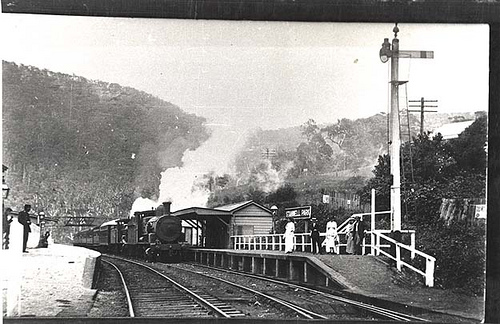<image>What time of year is this? It is ambiguous to determine the exact time of year, but it could be winter. What time of year is this? I don't know what time of year it is. It can be winter or summer. 